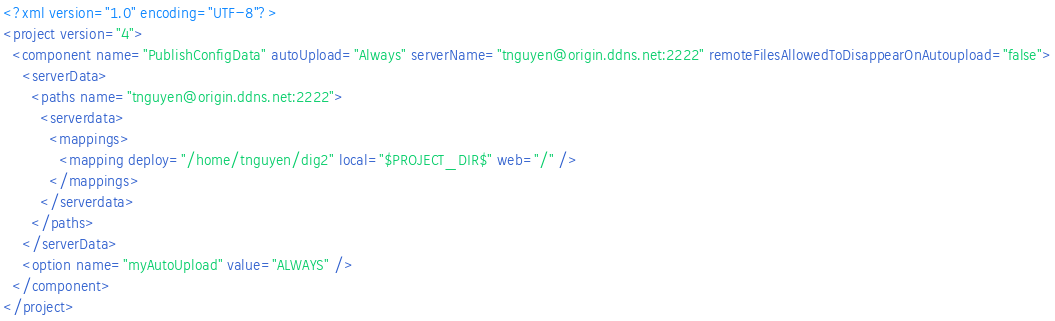<code> <loc_0><loc_0><loc_500><loc_500><_XML_><?xml version="1.0" encoding="UTF-8"?>
<project version="4">
  <component name="PublishConfigData" autoUpload="Always" serverName="tnguyen@origin.ddns.net:2222" remoteFilesAllowedToDisappearOnAutoupload="false">
    <serverData>
      <paths name="tnguyen@origin.ddns.net:2222">
        <serverdata>
          <mappings>
            <mapping deploy="/home/tnguyen/dig2" local="$PROJECT_DIR$" web="/" />
          </mappings>
        </serverdata>
      </paths>
    </serverData>
    <option name="myAutoUpload" value="ALWAYS" />
  </component>
</project></code> 